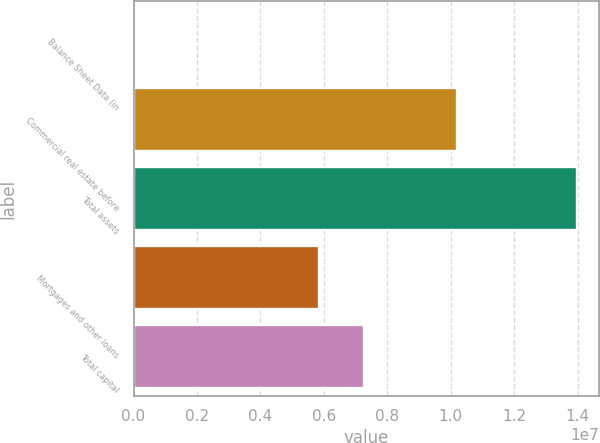Convert chart to OTSL. <chart><loc_0><loc_0><loc_500><loc_500><bar_chart><fcel>Balance Sheet Data (in<fcel>Commercial real estate before<fcel>Total assets<fcel>Mortgages and other loans<fcel>Total capital<nl><fcel>2017<fcel>1.02061e+07<fcel>1.39829e+07<fcel>5.85513e+06<fcel>7.25322e+06<nl></chart> 